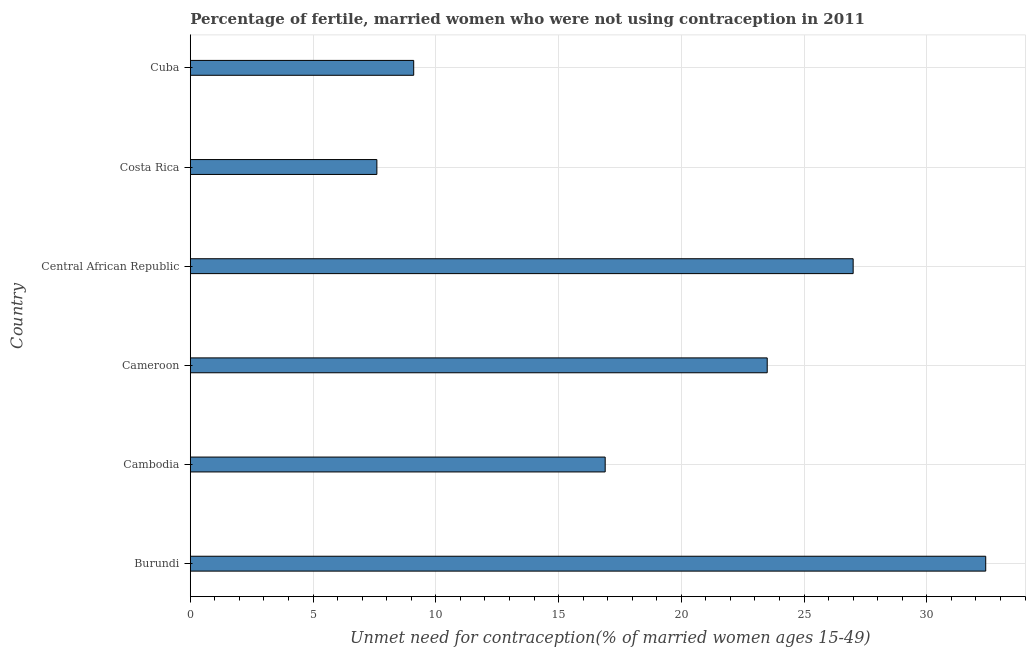Does the graph contain any zero values?
Your answer should be compact. No. What is the title of the graph?
Make the answer very short. Percentage of fertile, married women who were not using contraception in 2011. What is the label or title of the X-axis?
Make the answer very short.  Unmet need for contraception(% of married women ages 15-49). What is the number of married women who are not using contraception in Central African Republic?
Keep it short and to the point. 27. Across all countries, what is the maximum number of married women who are not using contraception?
Your answer should be very brief. 32.4. In which country was the number of married women who are not using contraception maximum?
Your answer should be very brief. Burundi. What is the sum of the number of married women who are not using contraception?
Keep it short and to the point. 116.5. What is the difference between the number of married women who are not using contraception in Burundi and Cameroon?
Give a very brief answer. 8.9. What is the average number of married women who are not using contraception per country?
Your answer should be compact. 19.42. What is the median number of married women who are not using contraception?
Provide a succinct answer. 20.2. What is the ratio of the number of married women who are not using contraception in Cameroon to that in Cuba?
Provide a short and direct response. 2.58. Is the number of married women who are not using contraception in Central African Republic less than that in Cuba?
Provide a short and direct response. No. Is the difference between the number of married women who are not using contraception in Cameroon and Central African Republic greater than the difference between any two countries?
Give a very brief answer. No. Is the sum of the number of married women who are not using contraception in Cambodia and Cuba greater than the maximum number of married women who are not using contraception across all countries?
Your answer should be very brief. No. What is the difference between the highest and the lowest number of married women who are not using contraception?
Your answer should be very brief. 24.8. Are all the bars in the graph horizontal?
Your answer should be compact. Yes. What is the difference between two consecutive major ticks on the X-axis?
Provide a short and direct response. 5. What is the  Unmet need for contraception(% of married women ages 15-49) of Burundi?
Make the answer very short. 32.4. What is the  Unmet need for contraception(% of married women ages 15-49) of Cambodia?
Keep it short and to the point. 16.9. What is the  Unmet need for contraception(% of married women ages 15-49) in Cameroon?
Your response must be concise. 23.5. What is the  Unmet need for contraception(% of married women ages 15-49) in Central African Republic?
Offer a terse response. 27. What is the  Unmet need for contraception(% of married women ages 15-49) of Costa Rica?
Offer a terse response. 7.6. What is the  Unmet need for contraception(% of married women ages 15-49) in Cuba?
Offer a very short reply. 9.1. What is the difference between the  Unmet need for contraception(% of married women ages 15-49) in Burundi and Cameroon?
Keep it short and to the point. 8.9. What is the difference between the  Unmet need for contraception(% of married women ages 15-49) in Burundi and Central African Republic?
Your answer should be compact. 5.4. What is the difference between the  Unmet need for contraception(% of married women ages 15-49) in Burundi and Costa Rica?
Offer a very short reply. 24.8. What is the difference between the  Unmet need for contraception(% of married women ages 15-49) in Burundi and Cuba?
Your answer should be very brief. 23.3. What is the difference between the  Unmet need for contraception(% of married women ages 15-49) in Cambodia and Central African Republic?
Give a very brief answer. -10.1. What is the difference between the  Unmet need for contraception(% of married women ages 15-49) in Cameroon and Costa Rica?
Your response must be concise. 15.9. What is the difference between the  Unmet need for contraception(% of married women ages 15-49) in Cameroon and Cuba?
Give a very brief answer. 14.4. What is the difference between the  Unmet need for contraception(% of married women ages 15-49) in Central African Republic and Costa Rica?
Give a very brief answer. 19.4. What is the difference between the  Unmet need for contraception(% of married women ages 15-49) in Central African Republic and Cuba?
Provide a succinct answer. 17.9. What is the difference between the  Unmet need for contraception(% of married women ages 15-49) in Costa Rica and Cuba?
Your answer should be compact. -1.5. What is the ratio of the  Unmet need for contraception(% of married women ages 15-49) in Burundi to that in Cambodia?
Provide a succinct answer. 1.92. What is the ratio of the  Unmet need for contraception(% of married women ages 15-49) in Burundi to that in Cameroon?
Your answer should be very brief. 1.38. What is the ratio of the  Unmet need for contraception(% of married women ages 15-49) in Burundi to that in Central African Republic?
Your answer should be compact. 1.2. What is the ratio of the  Unmet need for contraception(% of married women ages 15-49) in Burundi to that in Costa Rica?
Make the answer very short. 4.26. What is the ratio of the  Unmet need for contraception(% of married women ages 15-49) in Burundi to that in Cuba?
Your answer should be compact. 3.56. What is the ratio of the  Unmet need for contraception(% of married women ages 15-49) in Cambodia to that in Cameroon?
Give a very brief answer. 0.72. What is the ratio of the  Unmet need for contraception(% of married women ages 15-49) in Cambodia to that in Central African Republic?
Provide a succinct answer. 0.63. What is the ratio of the  Unmet need for contraception(% of married women ages 15-49) in Cambodia to that in Costa Rica?
Provide a succinct answer. 2.22. What is the ratio of the  Unmet need for contraception(% of married women ages 15-49) in Cambodia to that in Cuba?
Your answer should be compact. 1.86. What is the ratio of the  Unmet need for contraception(% of married women ages 15-49) in Cameroon to that in Central African Republic?
Keep it short and to the point. 0.87. What is the ratio of the  Unmet need for contraception(% of married women ages 15-49) in Cameroon to that in Costa Rica?
Provide a succinct answer. 3.09. What is the ratio of the  Unmet need for contraception(% of married women ages 15-49) in Cameroon to that in Cuba?
Provide a succinct answer. 2.58. What is the ratio of the  Unmet need for contraception(% of married women ages 15-49) in Central African Republic to that in Costa Rica?
Your answer should be very brief. 3.55. What is the ratio of the  Unmet need for contraception(% of married women ages 15-49) in Central African Republic to that in Cuba?
Offer a terse response. 2.97. What is the ratio of the  Unmet need for contraception(% of married women ages 15-49) in Costa Rica to that in Cuba?
Your answer should be very brief. 0.83. 